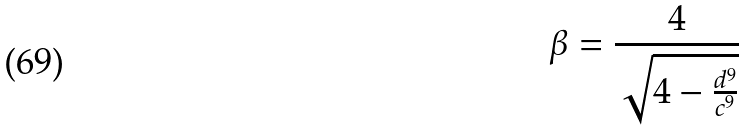<formula> <loc_0><loc_0><loc_500><loc_500>\beta = \frac { 4 } { \sqrt { 4 - \frac { d ^ { 9 } } { c ^ { 9 } } } }</formula> 